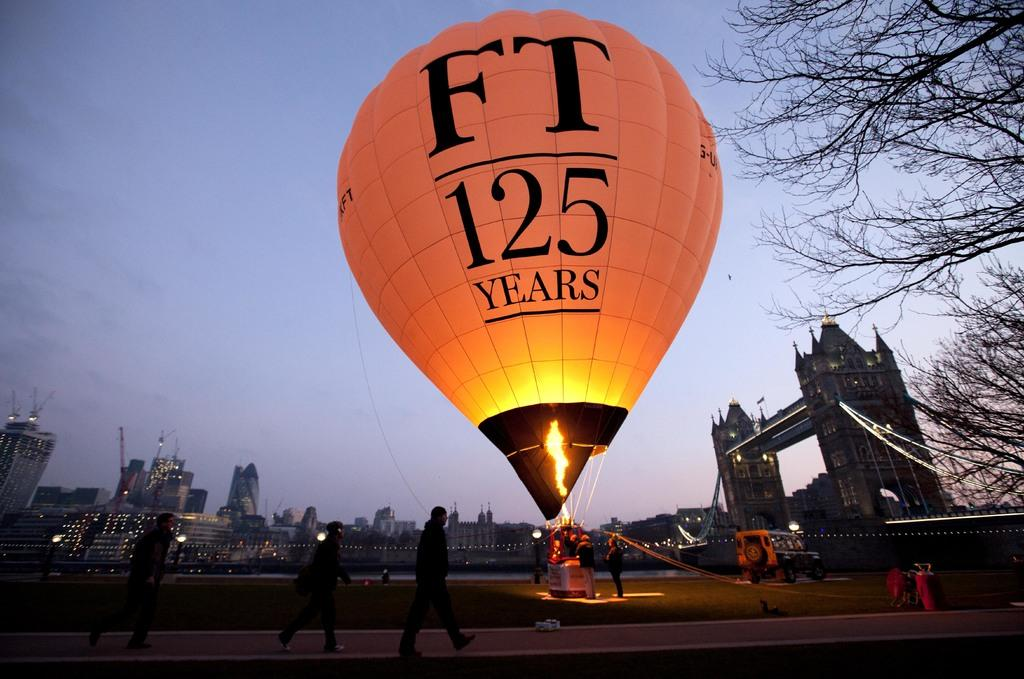Provide a one-sentence caption for the provided image. A hot air balloon taking off with an FT logo on it. 